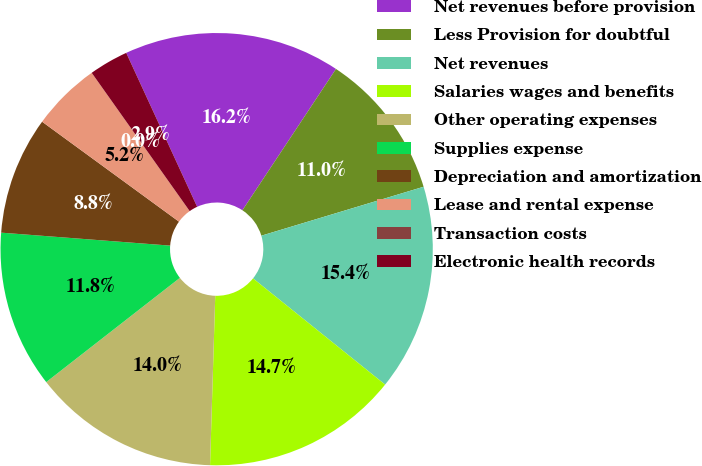Convert chart to OTSL. <chart><loc_0><loc_0><loc_500><loc_500><pie_chart><fcel>Net revenues before provision<fcel>Less Provision for doubtful<fcel>Net revenues<fcel>Salaries wages and benefits<fcel>Other operating expenses<fcel>Supplies expense<fcel>Depreciation and amortization<fcel>Lease and rental expense<fcel>Transaction costs<fcel>Electronic health records<nl><fcel>16.18%<fcel>11.03%<fcel>15.44%<fcel>14.71%<fcel>13.97%<fcel>11.76%<fcel>8.82%<fcel>5.15%<fcel>0.0%<fcel>2.94%<nl></chart> 